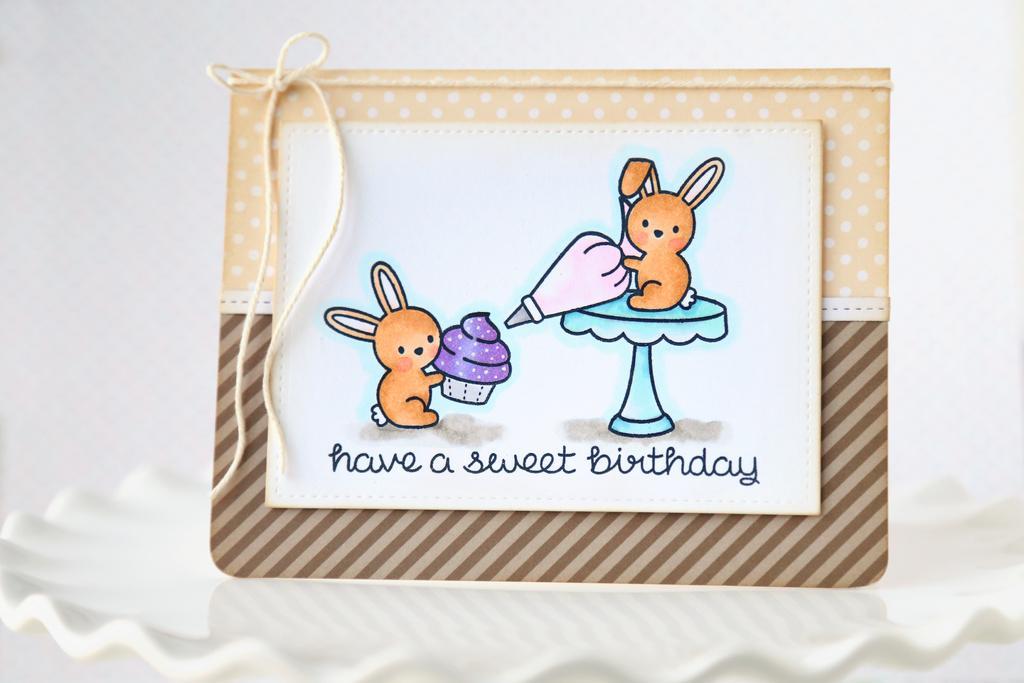Could you give a brief overview of what you see in this image? In this image there is a plate with a greeting card on it. On the greeting card there is a text and there are two toys and it is tied with a thread. 